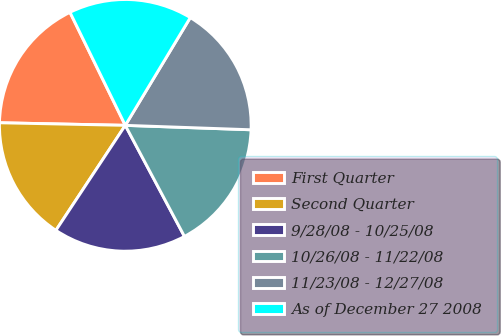Convert chart to OTSL. <chart><loc_0><loc_0><loc_500><loc_500><pie_chart><fcel>First Quarter<fcel>Second Quarter<fcel>9/28/08 - 10/25/08<fcel>10/26/08 - 11/22/08<fcel>11/23/08 - 12/27/08<fcel>As of December 27 2008<nl><fcel>17.43%<fcel>16.03%<fcel>17.08%<fcel>16.65%<fcel>16.92%<fcel>15.88%<nl></chart> 